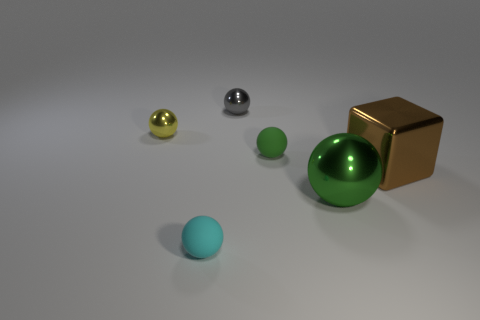What number of things are matte balls that are on the right side of the tiny cyan rubber thing or green spheres?
Your answer should be compact. 2. How many other objects are there of the same shape as the yellow thing?
Provide a succinct answer. 4. Are there more green rubber objects that are left of the cyan sphere than tiny cyan shiny cubes?
Provide a short and direct response. No. What size is the gray metal thing that is the same shape as the small cyan rubber thing?
Ensure brevity in your answer.  Small. What shape is the brown thing?
Give a very brief answer. Cube. What is the shape of the thing that is the same size as the brown cube?
Keep it short and to the point. Sphere. Are there any other things that are the same color as the large cube?
Ensure brevity in your answer.  No. What is the size of the yellow ball that is the same material as the tiny gray ball?
Keep it short and to the point. Small. Is the shape of the small green matte thing the same as the tiny rubber object that is in front of the large green metal sphere?
Your answer should be very brief. Yes. What size is the green rubber thing?
Your answer should be compact. Small. 